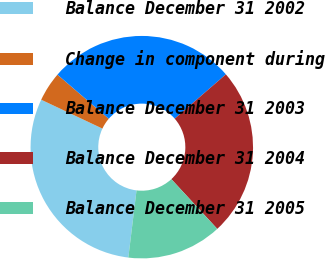<chart> <loc_0><loc_0><loc_500><loc_500><pie_chart><fcel>Balance December 31 2002<fcel>Change in component during<fcel>Balance December 31 2003<fcel>Balance December 31 2004<fcel>Balance December 31 2005<nl><fcel>30.08%<fcel>4.29%<fcel>27.34%<fcel>24.49%<fcel>13.8%<nl></chart> 